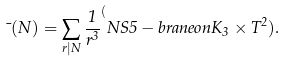Convert formula to latex. <formula><loc_0><loc_0><loc_500><loc_500>\mu ( N ) = \sum _ { r | N } \frac { 1 } { r ^ { 3 } } ^ { ( } N S 5 - b r a n e o n K _ { 3 } \times T ^ { 2 } ) .</formula> 